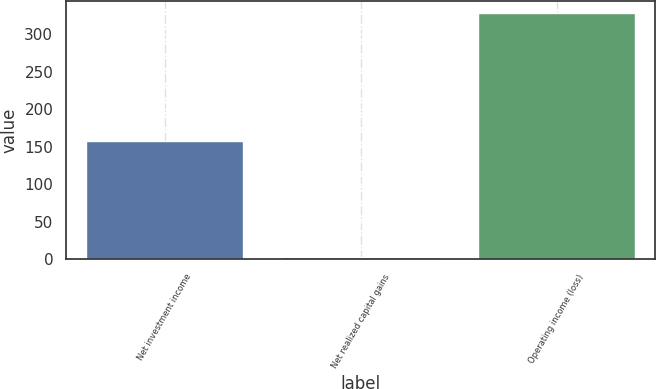<chart> <loc_0><loc_0><loc_500><loc_500><bar_chart><fcel>Net investment income<fcel>Net realized capital gains<fcel>Operating income (loss)<nl><fcel>158<fcel>3<fcel>328<nl></chart> 